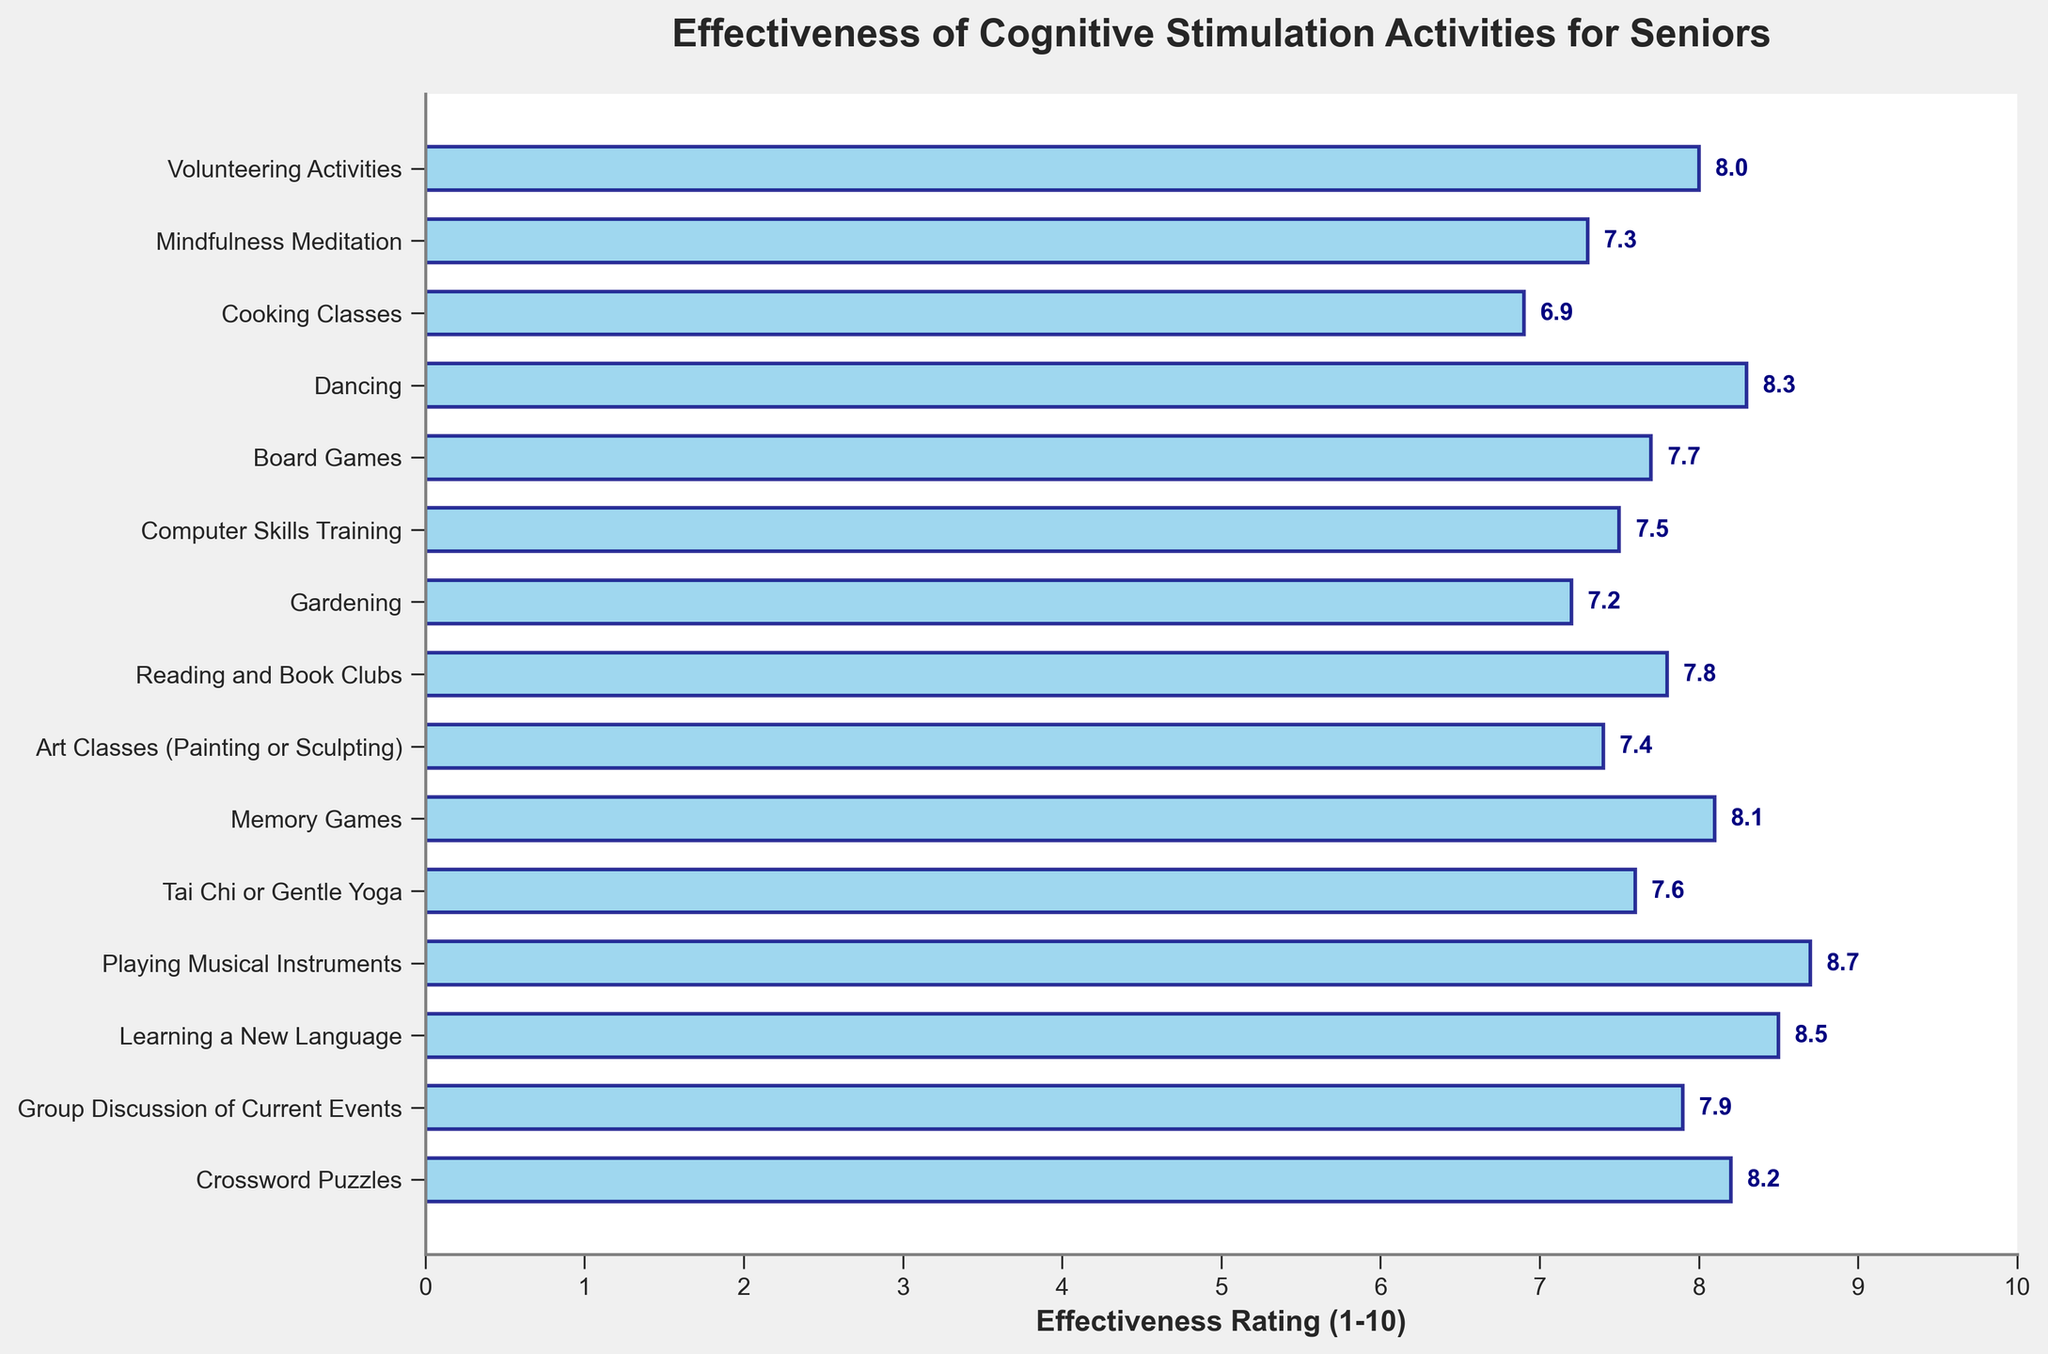Which activity received the highest effectiveness rating? Identify the bar with the highest value and refer to its label. The highest bar is labeled "Playing Musical Instruments" with a rating of 8.7.
Answer: Playing Musical Instruments Which activity received the lowest effectiveness rating? Identify the bar with the lowest value and refer to its label. The lowest bar is labeled "Cooking Classes" with a rating of 6.9.
Answer: Cooking Classes How many activities have a rating of 8 or higher? Count the number of bars with values 8 or higher. There are 7 activities: Crossword Puzzles, Learning a New Language, Playing Musical Instruments, Memory Games, Dancing, and Volunteering Activities.
Answer: 7 What is the difference in effectiveness ratings between Learning a New Language and Tai Chi? Subtract the rating of Tai Chi (7.6) from the rating of Learning a New Language (8.5). 8.5 - 7.6 = 0.9.
Answer: 0.9 Which two activities have the closest effectiveness ratings? Compare the differences between the ratings of all pairs of activities. "Reading and Book Clubs" (7.8) and "Group Discussion of Current Events" (7.9) have a difference of 0.1, which is the smallest.
Answer: Reading and Book Clubs and Group Discussion of Current Events Which activity is rated higher: Gardening or Art Classes? Compare the ratings of Gardening (7.2) and Art Classes (7.4). Art Classes have a higher rating.
Answer: Art Classes What is the average effectiveness rating of all activities? Sum all the ratings and divide by the number of activities. The total sum is 114.6 and there are 15 activities. So, 114.6 / 15 = 7.64.
Answer: 7.64 How many activities have an effectiveness rating between 7 and 8? Count the number of bars with values between 7 and 8 inclusive. There are 6 activities: Group Discussion of Current Events, Tai Chi or Gentle Yoga, Art Classes, Reading and Book Clubs, Computer Skills Training, and Board Games.
Answer: 6 Which activity is rated higher: Memory Games or Dancing? Compare the ratings of Memory Games (8.1) and Dancing (8.3). Dancing has a higher rating.
Answer: Dancing What is the combined effectiveness rating of Volunteering Activities and Mindfulness Meditation? Add the ratings of Volunteering Activities (8.0) and Mindfulness Meditation (7.3). 8.0 + 7.3 = 15.3
Answer: 15.3 